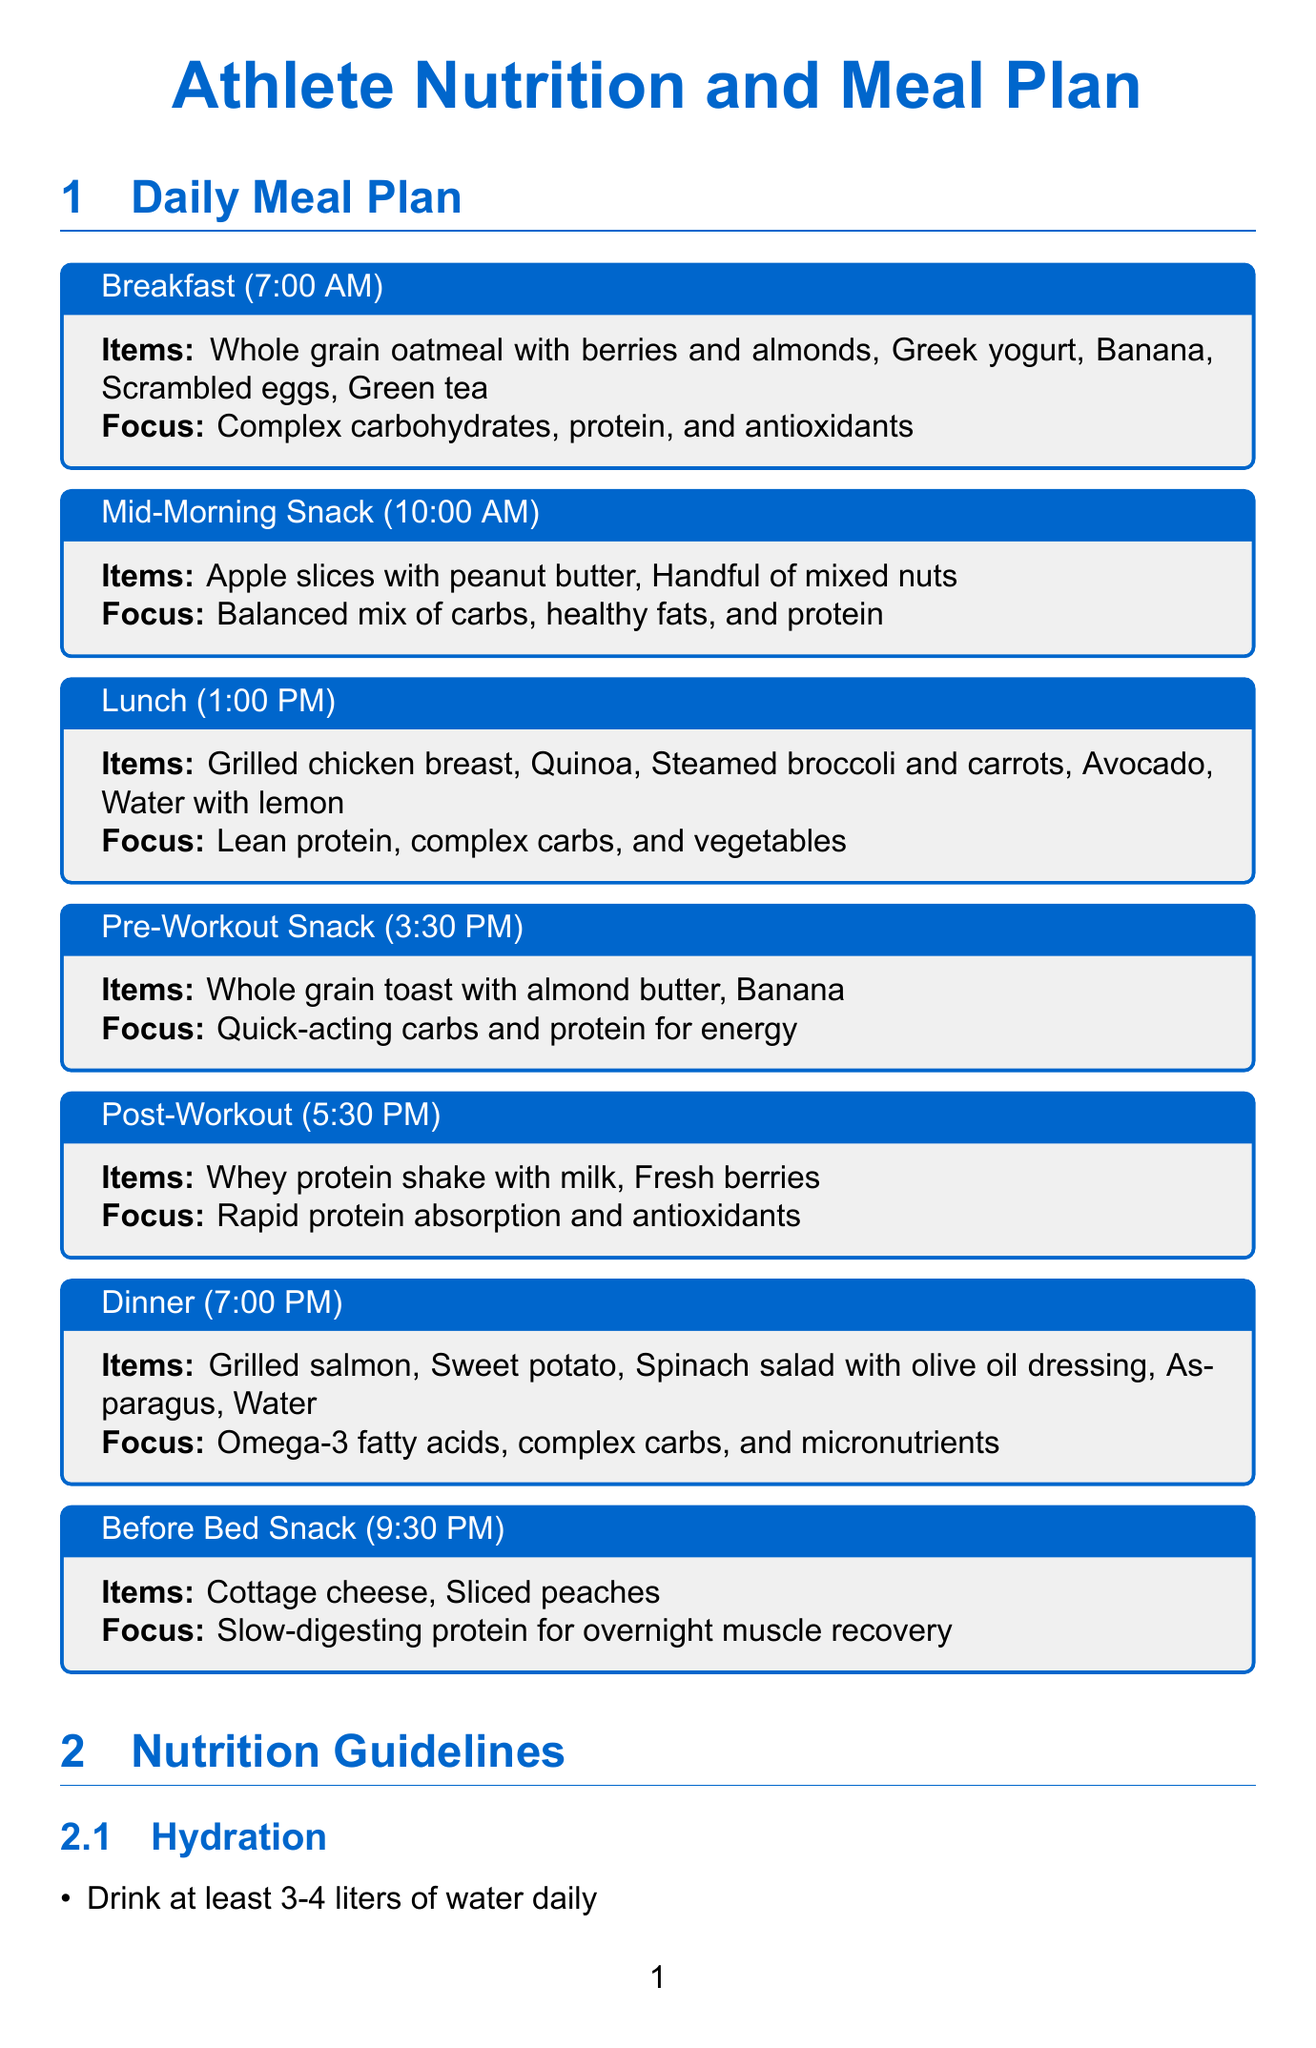What is the breakfast meal time? The breakfast meal time is explicitly mentioned in the meal plan section of the document.
Answer: 7:00 AM How many liters of water should an athlete drink daily? The hydration recommendations specify the amount of water an athlete should consume daily.
Answer: 3-4 liters What is included in the pre-workout snack? The pre-workout snack items are listed in the meal plan section.
Answer: Whole grain toast with almond butter, Banana What is the focus of the dinner meal? The nutritional focus for dinner is found in the meal plan section of the document.
Answer: Omega-3 fatty acids, complex carbs, and micronutrients What percentage of total calories should come from carbohydrates? The macronutrient guidelines provide a specific range for carbohydrate intake as a percentage of total calories.
Answer: 45-65% What should athletes do within 30 minutes post-workout? The nutrition timing guidelines specifically address actions to be taken after a workout.
Answer: Consume a recovery snack What is a coaching tip related to team meals? One of the coaching tips suggests organizing team meals for a specific purpose mentioned in the document.
Answer: Promote bonding and ensure proper nutrition before competitions What type of supplement is recommended for strength athletes? The supplements section outlines a specific supplement that may benefit strength and power athletes.
Answer: Creatine monohydrate 